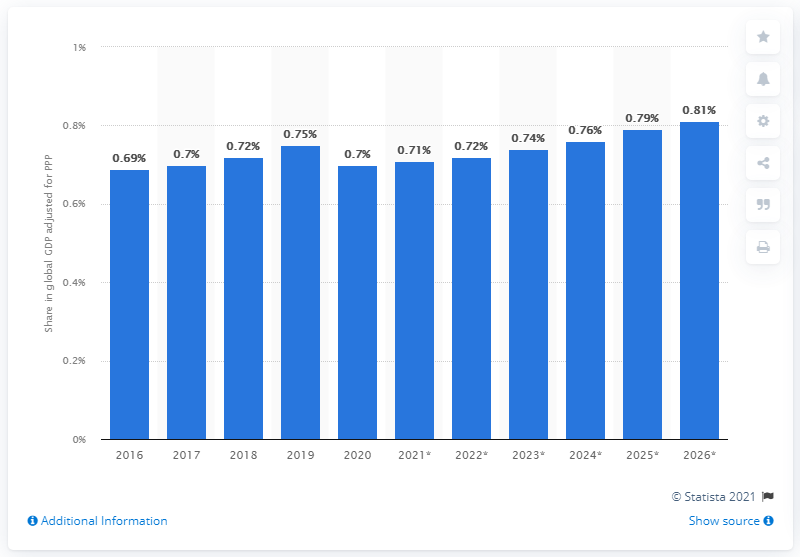Indicate a few pertinent items in this graphic. In 2020, the Philippines' share in the global gross domestic product adjusted for Purchasing Power Parity was 0.7%. 